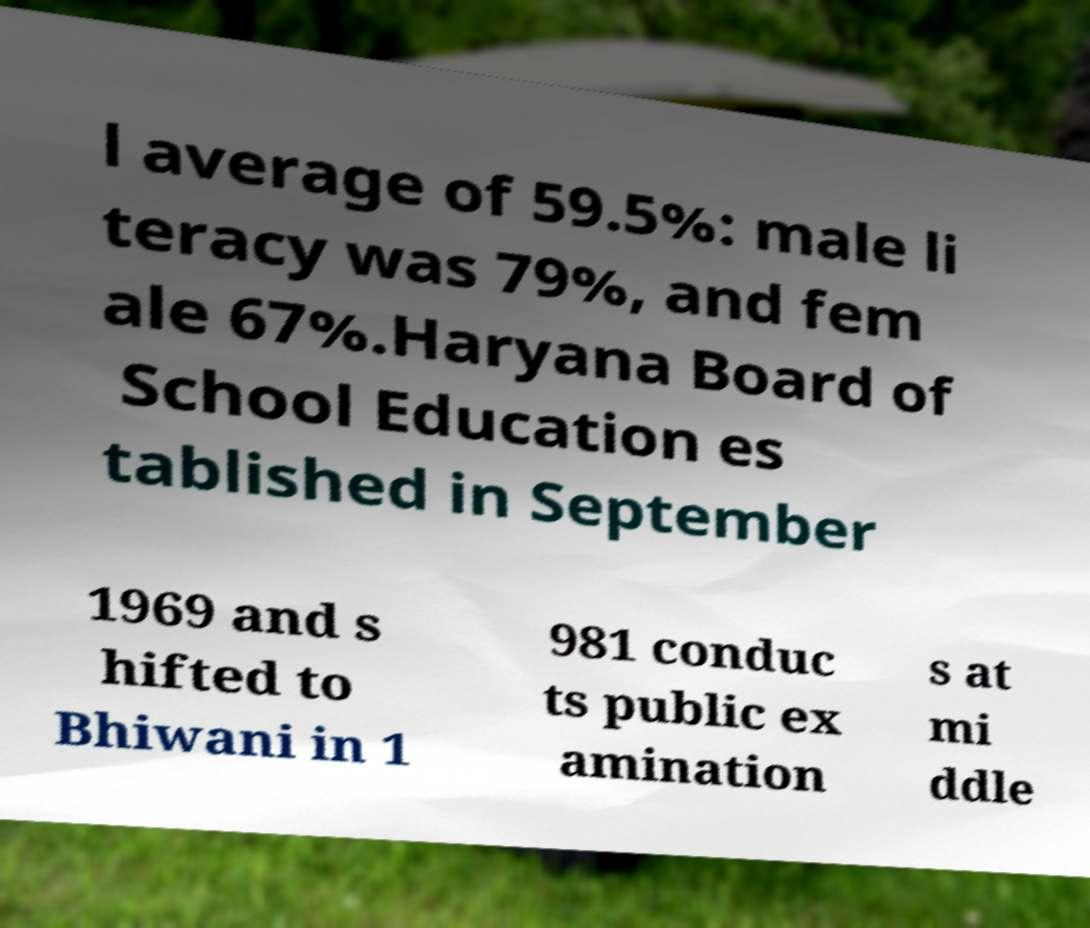Please read and relay the text visible in this image. What does it say? l average of 59.5%: male li teracy was 79%, and fem ale 67%.Haryana Board of School Education es tablished in September 1969 and s hifted to Bhiwani in 1 981 conduc ts public ex amination s at mi ddle 